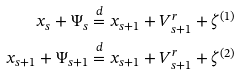Convert formula to latex. <formula><loc_0><loc_0><loc_500><loc_500>x _ { s } + \Psi _ { s } & \stackrel { d } { = } x _ { s + 1 } + V _ { s + 1 } ^ { r } + \zeta ^ { ( 1 ) } \\ x _ { s + 1 } + \Psi _ { s + 1 } & \stackrel { d } { = } x _ { s + 1 } + V _ { s + 1 } ^ { r } + \zeta ^ { ( 2 ) }</formula> 